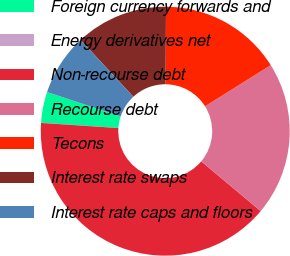<chart> <loc_0><loc_0><loc_500><loc_500><pie_chart><fcel>Foreign currency forwards and<fcel>Energy derivatives net<fcel>Non-recourse debt<fcel>Recourse debt<fcel>Tecons<fcel>Interest rate swaps<fcel>Interest rate caps and floors<nl><fcel>4.01%<fcel>0.02%<fcel>39.97%<fcel>19.99%<fcel>16.0%<fcel>12.0%<fcel>8.01%<nl></chart> 